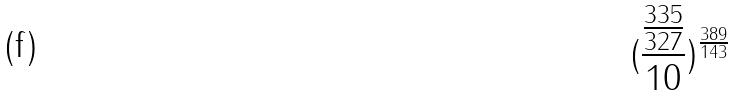<formula> <loc_0><loc_0><loc_500><loc_500>( \frac { \frac { 3 3 5 } { 3 2 7 } } { 1 0 } ) ^ { \frac { 3 8 9 } { 1 4 3 } }</formula> 